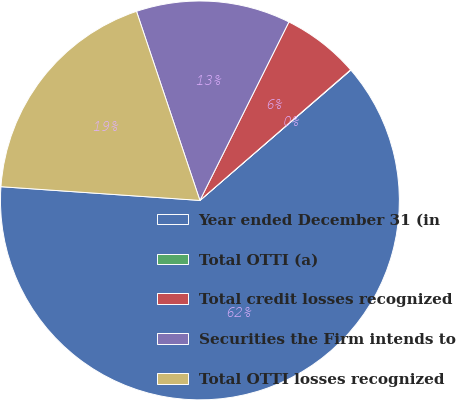Convert chart. <chart><loc_0><loc_0><loc_500><loc_500><pie_chart><fcel>Year ended December 31 (in<fcel>Total OTTI (a)<fcel>Total credit losses recognized<fcel>Securities the Firm intends to<fcel>Total OTTI losses recognized<nl><fcel>62.43%<fcel>0.03%<fcel>6.27%<fcel>12.51%<fcel>18.75%<nl></chart> 